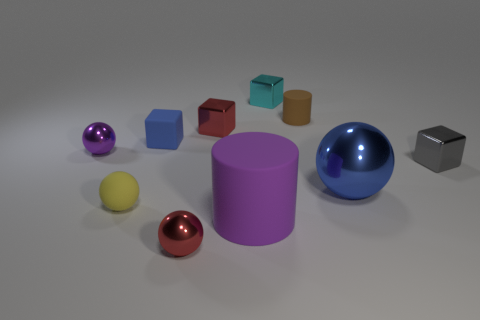There is a red thing that is the same shape as the gray shiny object; what is its size?
Your response must be concise. Small. What number of other things are there of the same shape as the small gray shiny thing?
Offer a terse response. 3. What is the color of the ball that is in front of the small matte ball?
Provide a succinct answer. Red. Are the purple cylinder and the gray thing made of the same material?
Give a very brief answer. No. What number of things are cyan balls or shiny things that are in front of the big sphere?
Your response must be concise. 1. There is a ball that is the same color as the large matte cylinder; what is its size?
Ensure brevity in your answer.  Small. There is a rubber thing in front of the small yellow rubber object; what shape is it?
Provide a succinct answer. Cylinder. Is the color of the metallic ball on the right side of the tiny matte cylinder the same as the small matte cube?
Ensure brevity in your answer.  Yes. What is the material of the ball that is the same color as the large matte cylinder?
Your answer should be very brief. Metal. There is a rubber cylinder that is on the right side of the cyan block; is it the same size as the blue ball?
Your answer should be compact. No. 